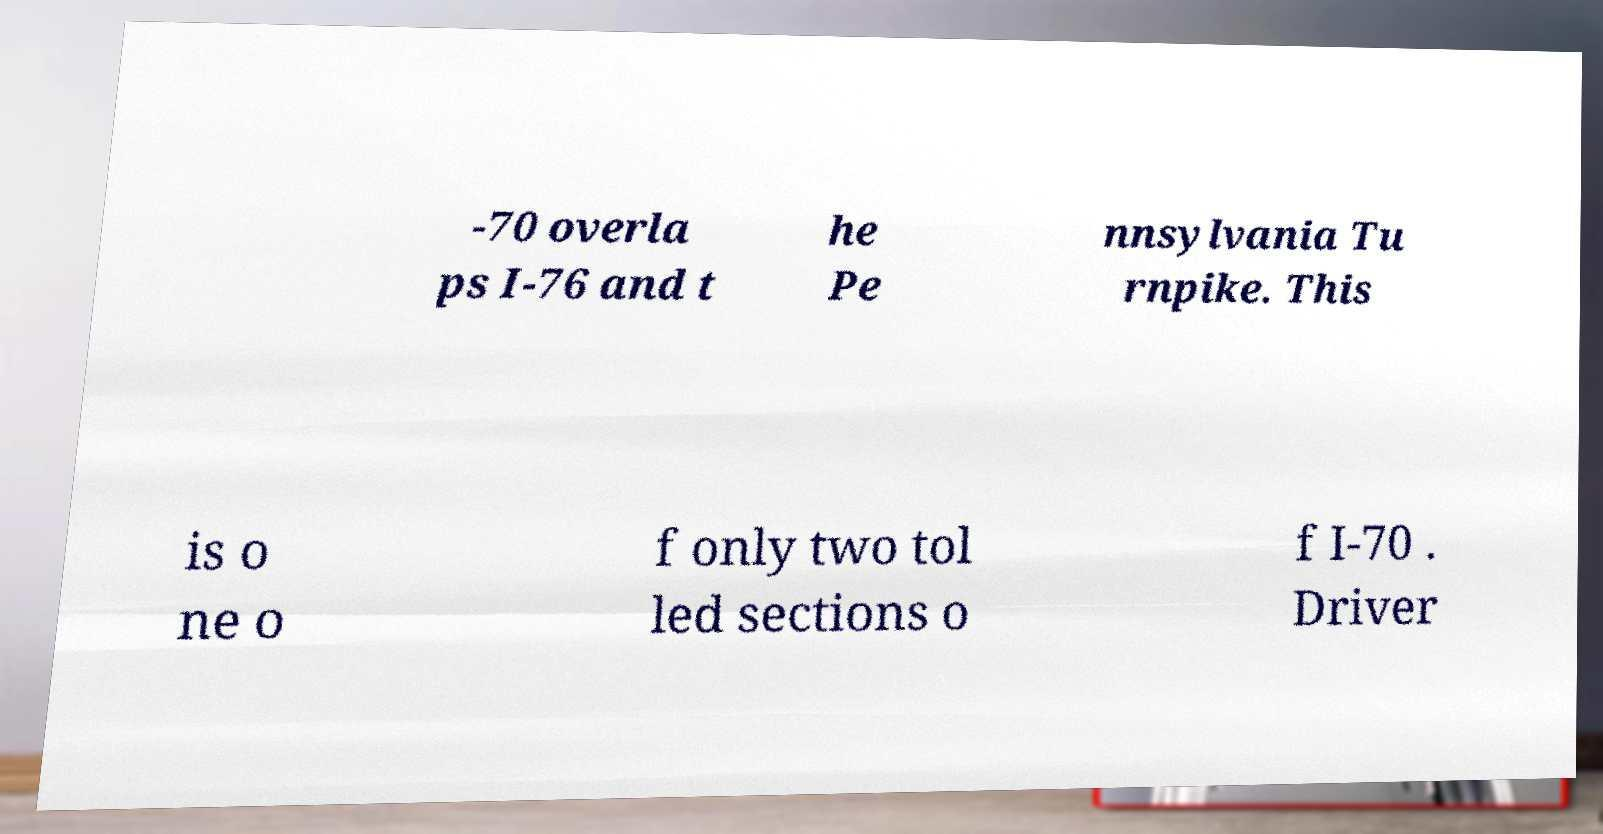What messages or text are displayed in this image? I need them in a readable, typed format. -70 overla ps I-76 and t he Pe nnsylvania Tu rnpike. This is o ne o f only two tol led sections o f I-70 . Driver 